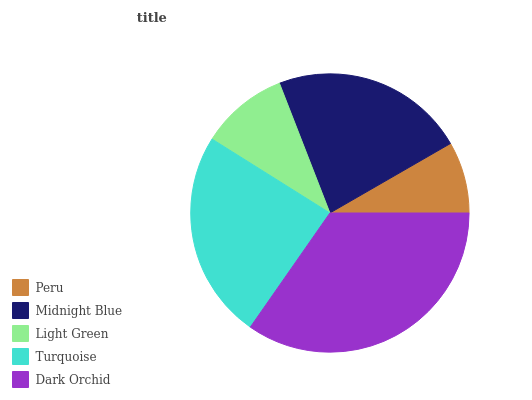Is Peru the minimum?
Answer yes or no. Yes. Is Dark Orchid the maximum?
Answer yes or no. Yes. Is Midnight Blue the minimum?
Answer yes or no. No. Is Midnight Blue the maximum?
Answer yes or no. No. Is Midnight Blue greater than Peru?
Answer yes or no. Yes. Is Peru less than Midnight Blue?
Answer yes or no. Yes. Is Peru greater than Midnight Blue?
Answer yes or no. No. Is Midnight Blue less than Peru?
Answer yes or no. No. Is Midnight Blue the high median?
Answer yes or no. Yes. Is Midnight Blue the low median?
Answer yes or no. Yes. Is Turquoise the high median?
Answer yes or no. No. Is Light Green the low median?
Answer yes or no. No. 